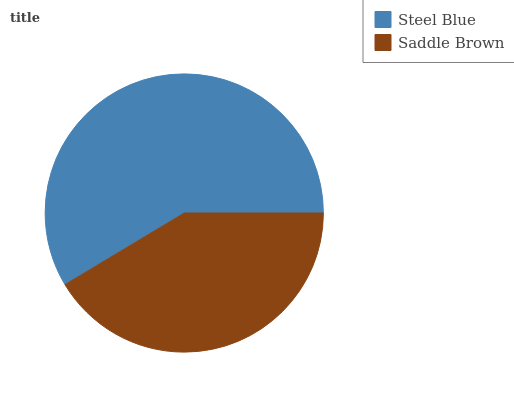Is Saddle Brown the minimum?
Answer yes or no. Yes. Is Steel Blue the maximum?
Answer yes or no. Yes. Is Saddle Brown the maximum?
Answer yes or no. No. Is Steel Blue greater than Saddle Brown?
Answer yes or no. Yes. Is Saddle Brown less than Steel Blue?
Answer yes or no. Yes. Is Saddle Brown greater than Steel Blue?
Answer yes or no. No. Is Steel Blue less than Saddle Brown?
Answer yes or no. No. Is Steel Blue the high median?
Answer yes or no. Yes. Is Saddle Brown the low median?
Answer yes or no. Yes. Is Saddle Brown the high median?
Answer yes or no. No. Is Steel Blue the low median?
Answer yes or no. No. 